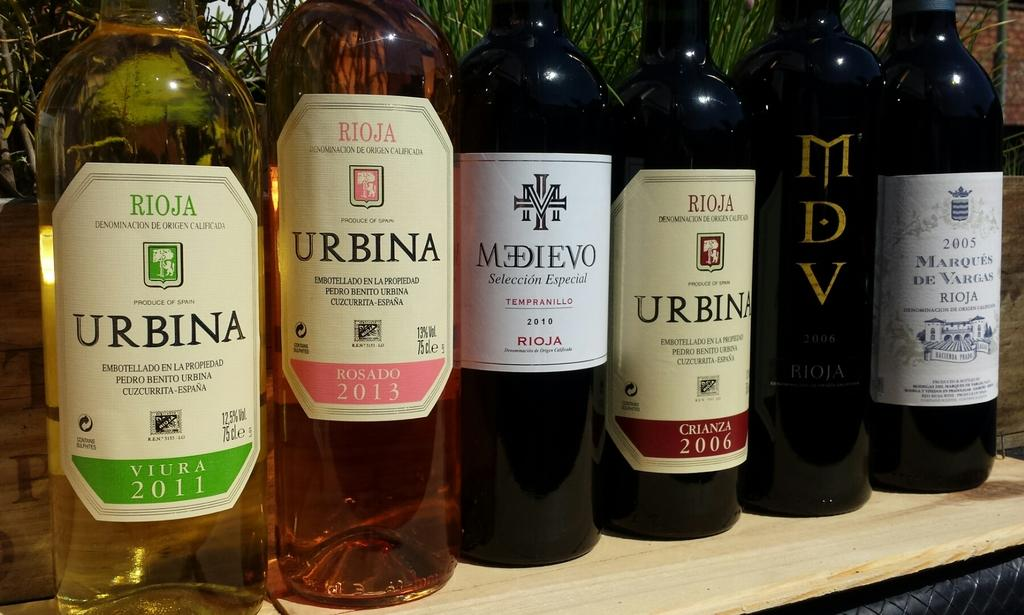<image>
Present a compact description of the photo's key features. 5 different bottles of wines, both white and red are on the shelf with 3 of them being Urbina brand. 